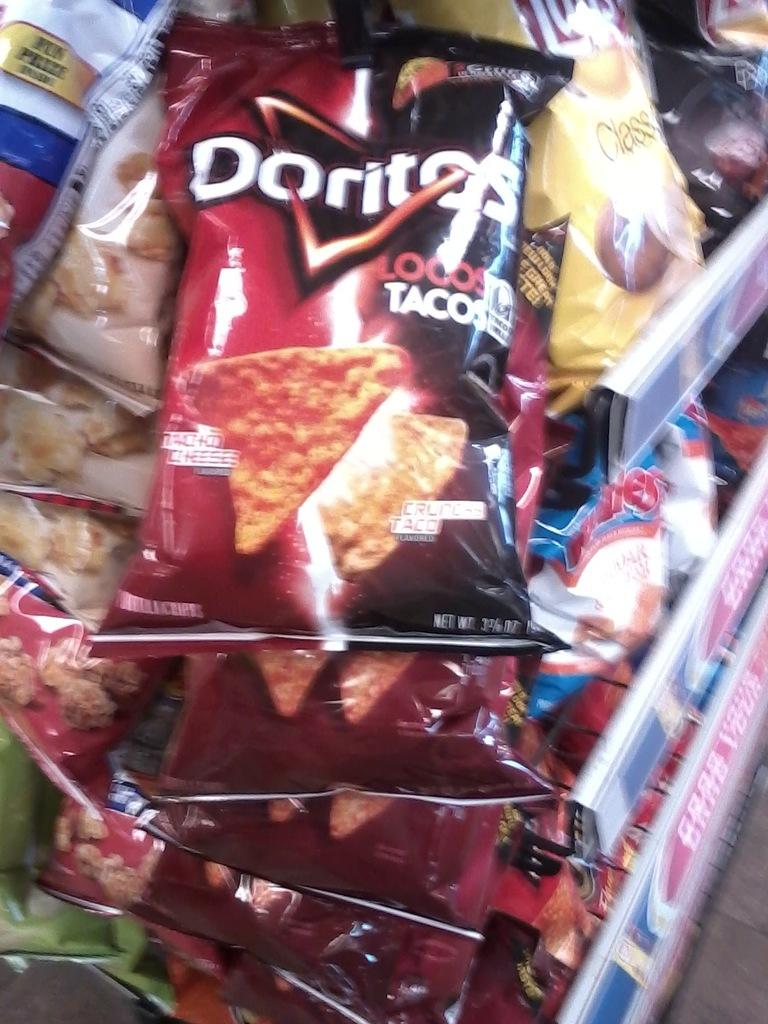Provide a one-sentence caption for the provided image. Bags of Doritos Locos Tacos flavor chips are hanging on a rack. 